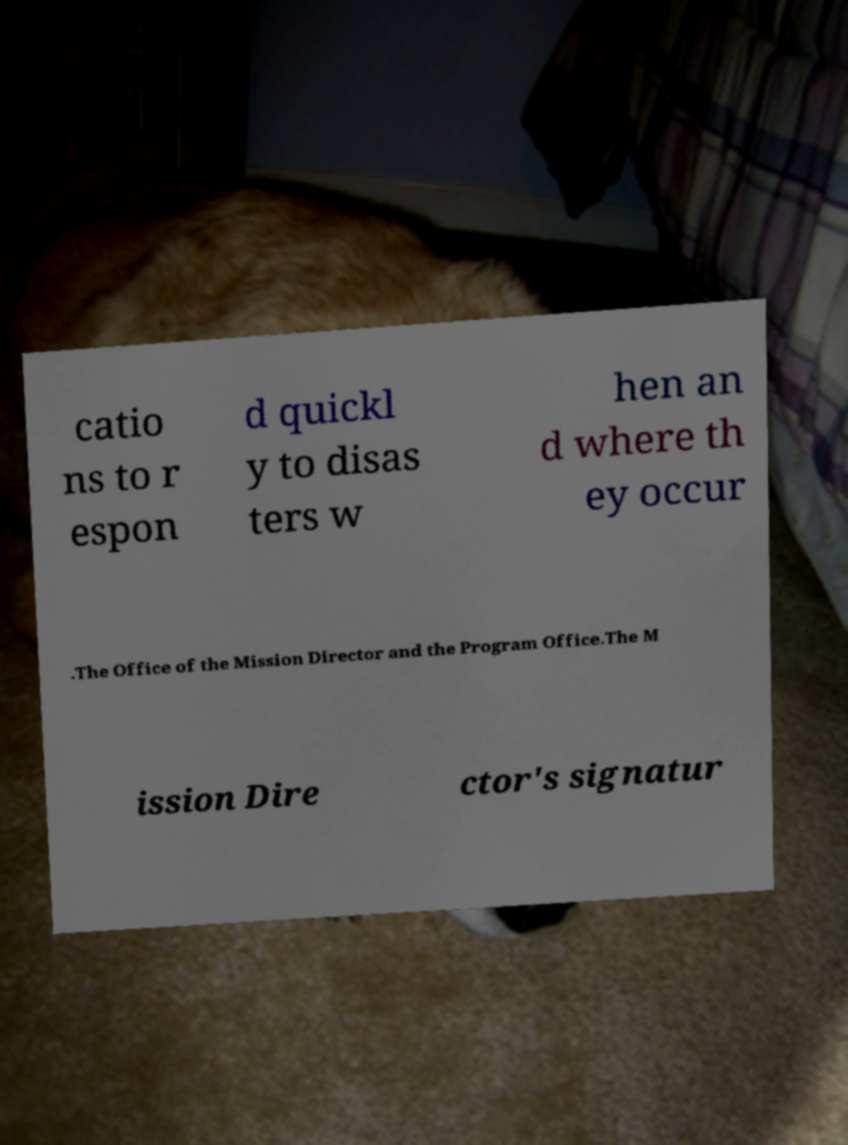Please identify and transcribe the text found in this image. catio ns to r espon d quickl y to disas ters w hen an d where th ey occur .The Office of the Mission Director and the Program Office.The M ission Dire ctor's signatur 